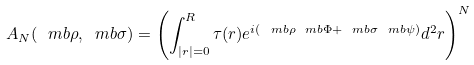<formula> <loc_0><loc_0><loc_500><loc_500>A _ { N } ( { \ m b \rho } , { \ m b \sigma } ) = \left ( \int _ { | { r } | = 0 } ^ { R } \tau ( { r } ) e ^ { i ( { \ m b \rho } { \ m b \Phi } + { \ m b \sigma } { \ m b \psi } ) } d ^ { 2 } { r } \right ) ^ { N }</formula> 